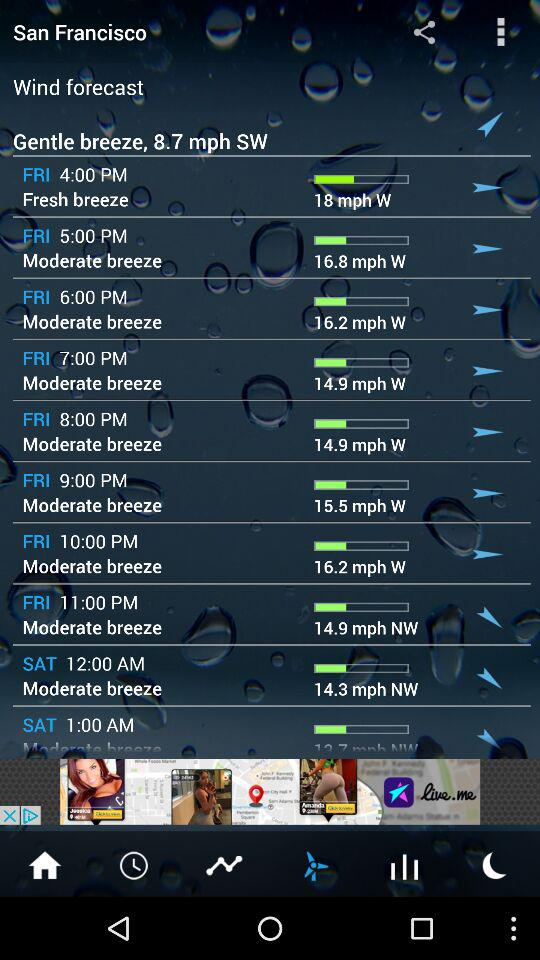What is the wind speed on Friday at 9 p.m.? The wind speed on Friday at 9 p.m. is 15.5 mph. 